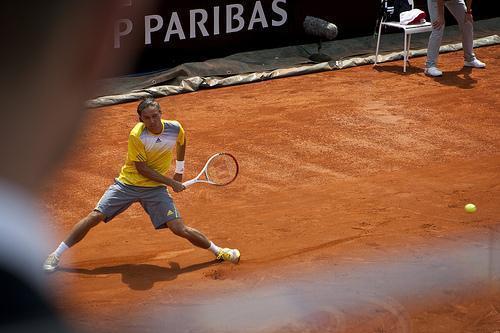How many people are shown in the photo?
Give a very brief answer. 3. How many tennis balls are visible?
Give a very brief answer. 1. How many of the letters on the sign are "a"?
Give a very brief answer. 2. 